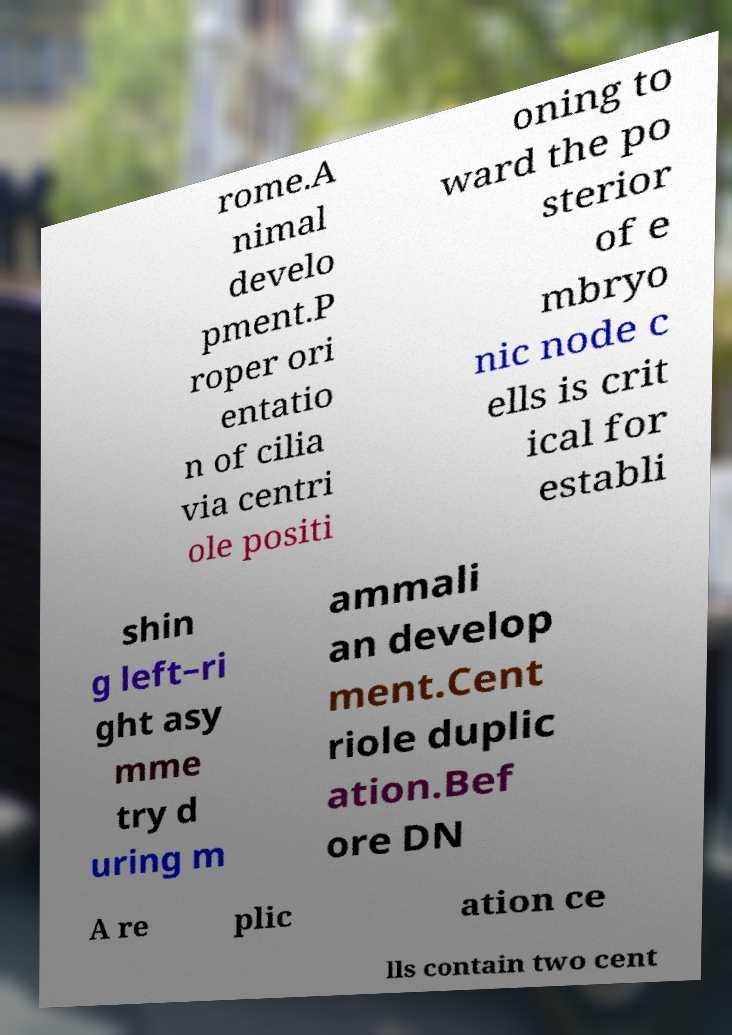I need the written content from this picture converted into text. Can you do that? rome.A nimal develo pment.P roper ori entatio n of cilia via centri ole positi oning to ward the po sterior of e mbryo nic node c ells is crit ical for establi shin g left–ri ght asy mme try d uring m ammali an develop ment.Cent riole duplic ation.Bef ore DN A re plic ation ce lls contain two cent 